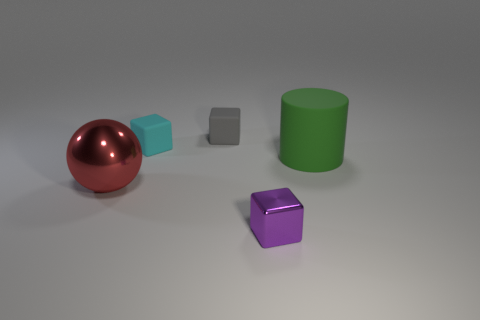Subtract all gray cubes. How many cubes are left? 2 Add 3 red balls. How many objects exist? 8 Subtract 1 cylinders. How many cylinders are left? 0 Subtract all gray cubes. How many cubes are left? 2 Subtract all cylinders. How many objects are left? 4 Subtract all red blocks. Subtract all cyan balls. How many blocks are left? 3 Subtract all yellow cylinders. How many gray blocks are left? 1 Subtract all large shiny things. Subtract all tiny cyan things. How many objects are left? 3 Add 1 red shiny things. How many red shiny things are left? 2 Add 2 cyan rubber things. How many cyan rubber things exist? 3 